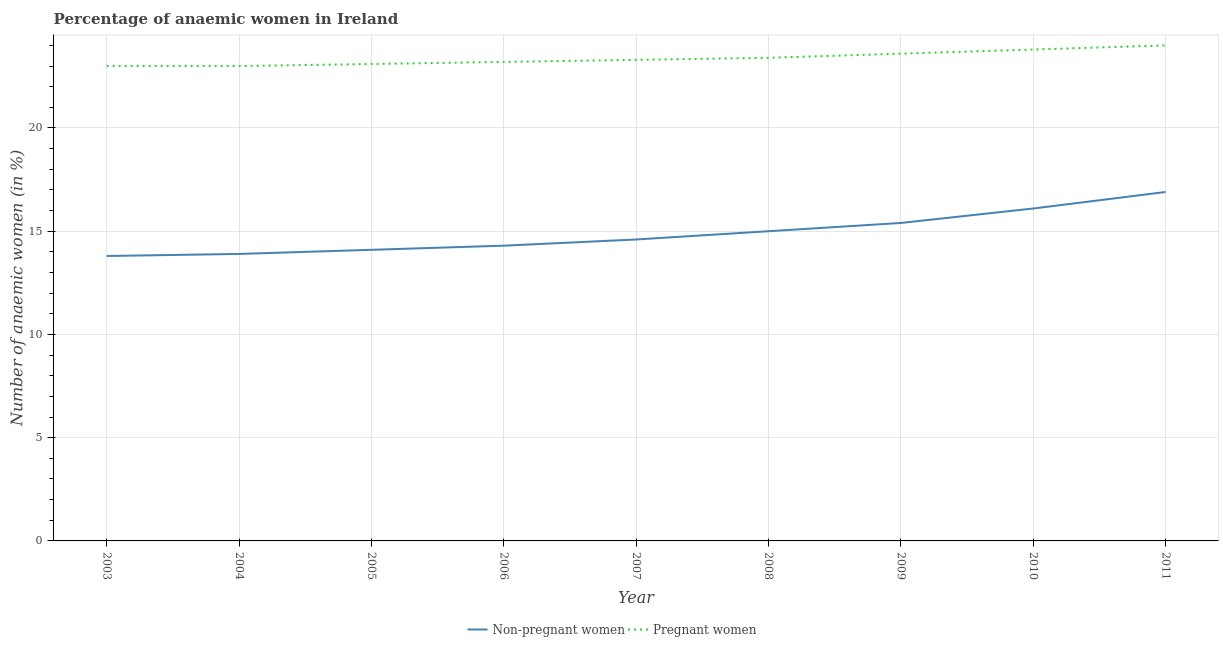Does the line corresponding to percentage of pregnant anaemic women intersect with the line corresponding to percentage of non-pregnant anaemic women?
Keep it short and to the point. No. Is the number of lines equal to the number of legend labels?
Provide a succinct answer. Yes. What is the percentage of pregnant anaemic women in 2008?
Give a very brief answer. 23.4. In which year was the percentage of non-pregnant anaemic women maximum?
Give a very brief answer. 2011. In which year was the percentage of non-pregnant anaemic women minimum?
Your answer should be very brief. 2003. What is the total percentage of non-pregnant anaemic women in the graph?
Your answer should be compact. 134.1. What is the difference between the percentage of pregnant anaemic women in 2006 and that in 2009?
Give a very brief answer. -0.4. What is the difference between the percentage of non-pregnant anaemic women in 2005 and the percentage of pregnant anaemic women in 2009?
Give a very brief answer. -9.5. What is the average percentage of pregnant anaemic women per year?
Your answer should be compact. 23.38. In the year 2009, what is the difference between the percentage of non-pregnant anaemic women and percentage of pregnant anaemic women?
Keep it short and to the point. -8.2. What is the ratio of the percentage of pregnant anaemic women in 2009 to that in 2011?
Your answer should be very brief. 0.98. Is the percentage of non-pregnant anaemic women in 2005 less than that in 2006?
Your response must be concise. Yes. Is the difference between the percentage of non-pregnant anaemic women in 2006 and 2011 greater than the difference between the percentage of pregnant anaemic women in 2006 and 2011?
Offer a very short reply. No. What is the difference between the highest and the second highest percentage of pregnant anaemic women?
Ensure brevity in your answer.  0.2. What is the difference between the highest and the lowest percentage of non-pregnant anaemic women?
Your answer should be compact. 3.1. Is the sum of the percentage of non-pregnant anaemic women in 2004 and 2011 greater than the maximum percentage of pregnant anaemic women across all years?
Give a very brief answer. Yes. Is the percentage of pregnant anaemic women strictly greater than the percentage of non-pregnant anaemic women over the years?
Give a very brief answer. Yes. How many years are there in the graph?
Ensure brevity in your answer.  9. Are the values on the major ticks of Y-axis written in scientific E-notation?
Offer a very short reply. No. Does the graph contain grids?
Give a very brief answer. Yes. Where does the legend appear in the graph?
Make the answer very short. Bottom center. How many legend labels are there?
Give a very brief answer. 2. How are the legend labels stacked?
Your answer should be compact. Horizontal. What is the title of the graph?
Your response must be concise. Percentage of anaemic women in Ireland. Does "Subsidies" appear as one of the legend labels in the graph?
Make the answer very short. No. What is the label or title of the Y-axis?
Your response must be concise. Number of anaemic women (in %). What is the Number of anaemic women (in %) of Pregnant women in 2004?
Provide a succinct answer. 23. What is the Number of anaemic women (in %) in Non-pregnant women in 2005?
Your answer should be compact. 14.1. What is the Number of anaemic women (in %) of Pregnant women in 2005?
Your answer should be very brief. 23.1. What is the Number of anaemic women (in %) of Pregnant women in 2006?
Your response must be concise. 23.2. What is the Number of anaemic women (in %) of Pregnant women in 2007?
Keep it short and to the point. 23.3. What is the Number of anaemic women (in %) in Pregnant women in 2008?
Offer a terse response. 23.4. What is the Number of anaemic women (in %) in Non-pregnant women in 2009?
Ensure brevity in your answer.  15.4. What is the Number of anaemic women (in %) of Pregnant women in 2009?
Give a very brief answer. 23.6. What is the Number of anaemic women (in %) in Non-pregnant women in 2010?
Offer a very short reply. 16.1. What is the Number of anaemic women (in %) in Pregnant women in 2010?
Provide a succinct answer. 23.8. What is the Number of anaemic women (in %) of Non-pregnant women in 2011?
Make the answer very short. 16.9. What is the Number of anaemic women (in %) of Pregnant women in 2011?
Ensure brevity in your answer.  24. Across all years, what is the maximum Number of anaemic women (in %) of Pregnant women?
Make the answer very short. 24. Across all years, what is the minimum Number of anaemic women (in %) of Non-pregnant women?
Your answer should be compact. 13.8. Across all years, what is the minimum Number of anaemic women (in %) of Pregnant women?
Your response must be concise. 23. What is the total Number of anaemic women (in %) in Non-pregnant women in the graph?
Make the answer very short. 134.1. What is the total Number of anaemic women (in %) in Pregnant women in the graph?
Give a very brief answer. 210.4. What is the difference between the Number of anaemic women (in %) in Non-pregnant women in 2003 and that in 2004?
Your answer should be very brief. -0.1. What is the difference between the Number of anaemic women (in %) of Non-pregnant women in 2003 and that in 2007?
Make the answer very short. -0.8. What is the difference between the Number of anaemic women (in %) of Pregnant women in 2003 and that in 2007?
Offer a very short reply. -0.3. What is the difference between the Number of anaemic women (in %) of Non-pregnant women in 2003 and that in 2008?
Provide a short and direct response. -1.2. What is the difference between the Number of anaemic women (in %) in Pregnant women in 2003 and that in 2008?
Your answer should be very brief. -0.4. What is the difference between the Number of anaemic women (in %) in Non-pregnant women in 2003 and that in 2009?
Keep it short and to the point. -1.6. What is the difference between the Number of anaemic women (in %) of Non-pregnant women in 2003 and that in 2010?
Your answer should be compact. -2.3. What is the difference between the Number of anaemic women (in %) of Pregnant women in 2004 and that in 2005?
Ensure brevity in your answer.  -0.1. What is the difference between the Number of anaemic women (in %) in Non-pregnant women in 2004 and that in 2007?
Offer a terse response. -0.7. What is the difference between the Number of anaemic women (in %) of Non-pregnant women in 2004 and that in 2008?
Offer a terse response. -1.1. What is the difference between the Number of anaemic women (in %) in Pregnant women in 2004 and that in 2009?
Your answer should be very brief. -0.6. What is the difference between the Number of anaemic women (in %) of Non-pregnant women in 2004 and that in 2010?
Your answer should be very brief. -2.2. What is the difference between the Number of anaemic women (in %) in Pregnant women in 2004 and that in 2010?
Give a very brief answer. -0.8. What is the difference between the Number of anaemic women (in %) of Non-pregnant women in 2004 and that in 2011?
Ensure brevity in your answer.  -3. What is the difference between the Number of anaemic women (in %) in Pregnant women in 2004 and that in 2011?
Provide a short and direct response. -1. What is the difference between the Number of anaemic women (in %) of Non-pregnant women in 2005 and that in 2006?
Your answer should be compact. -0.2. What is the difference between the Number of anaemic women (in %) of Pregnant women in 2005 and that in 2006?
Offer a very short reply. -0.1. What is the difference between the Number of anaemic women (in %) in Pregnant women in 2005 and that in 2009?
Ensure brevity in your answer.  -0.5. What is the difference between the Number of anaemic women (in %) in Pregnant women in 2005 and that in 2010?
Offer a terse response. -0.7. What is the difference between the Number of anaemic women (in %) of Non-pregnant women in 2005 and that in 2011?
Keep it short and to the point. -2.8. What is the difference between the Number of anaemic women (in %) in Non-pregnant women in 2006 and that in 2009?
Offer a terse response. -1.1. What is the difference between the Number of anaemic women (in %) in Pregnant women in 2006 and that in 2009?
Your answer should be very brief. -0.4. What is the difference between the Number of anaemic women (in %) of Non-pregnant women in 2006 and that in 2011?
Keep it short and to the point. -2.6. What is the difference between the Number of anaemic women (in %) in Pregnant women in 2007 and that in 2008?
Provide a succinct answer. -0.1. What is the difference between the Number of anaemic women (in %) in Pregnant women in 2007 and that in 2009?
Offer a very short reply. -0.3. What is the difference between the Number of anaemic women (in %) in Pregnant women in 2008 and that in 2011?
Your answer should be very brief. -0.6. What is the difference between the Number of anaemic women (in %) in Non-pregnant women in 2009 and that in 2010?
Offer a terse response. -0.7. What is the difference between the Number of anaemic women (in %) in Pregnant women in 2009 and that in 2010?
Keep it short and to the point. -0.2. What is the difference between the Number of anaemic women (in %) in Non-pregnant women in 2003 and the Number of anaemic women (in %) in Pregnant women in 2004?
Give a very brief answer. -9.2. What is the difference between the Number of anaemic women (in %) of Non-pregnant women in 2003 and the Number of anaemic women (in %) of Pregnant women in 2011?
Provide a short and direct response. -10.2. What is the difference between the Number of anaemic women (in %) in Non-pregnant women in 2004 and the Number of anaemic women (in %) in Pregnant women in 2005?
Your response must be concise. -9.2. What is the difference between the Number of anaemic women (in %) in Non-pregnant women in 2004 and the Number of anaemic women (in %) in Pregnant women in 2007?
Your response must be concise. -9.4. What is the difference between the Number of anaemic women (in %) in Non-pregnant women in 2004 and the Number of anaemic women (in %) in Pregnant women in 2008?
Keep it short and to the point. -9.5. What is the difference between the Number of anaemic women (in %) in Non-pregnant women in 2004 and the Number of anaemic women (in %) in Pregnant women in 2010?
Give a very brief answer. -9.9. What is the difference between the Number of anaemic women (in %) in Non-pregnant women in 2005 and the Number of anaemic women (in %) in Pregnant women in 2006?
Make the answer very short. -9.1. What is the difference between the Number of anaemic women (in %) in Non-pregnant women in 2005 and the Number of anaemic women (in %) in Pregnant women in 2007?
Ensure brevity in your answer.  -9.2. What is the difference between the Number of anaemic women (in %) in Non-pregnant women in 2005 and the Number of anaemic women (in %) in Pregnant women in 2008?
Your answer should be very brief. -9.3. What is the difference between the Number of anaemic women (in %) in Non-pregnant women in 2006 and the Number of anaemic women (in %) in Pregnant women in 2007?
Your response must be concise. -9. What is the difference between the Number of anaemic women (in %) of Non-pregnant women in 2006 and the Number of anaemic women (in %) of Pregnant women in 2008?
Provide a succinct answer. -9.1. What is the difference between the Number of anaemic women (in %) of Non-pregnant women in 2006 and the Number of anaemic women (in %) of Pregnant women in 2011?
Offer a very short reply. -9.7. What is the difference between the Number of anaemic women (in %) of Non-pregnant women in 2007 and the Number of anaemic women (in %) of Pregnant women in 2008?
Your response must be concise. -8.8. What is the difference between the Number of anaemic women (in %) of Non-pregnant women in 2007 and the Number of anaemic women (in %) of Pregnant women in 2011?
Offer a terse response. -9.4. What is the difference between the Number of anaemic women (in %) in Non-pregnant women in 2008 and the Number of anaemic women (in %) in Pregnant women in 2011?
Offer a terse response. -9. What is the average Number of anaemic women (in %) of Non-pregnant women per year?
Offer a terse response. 14.9. What is the average Number of anaemic women (in %) in Pregnant women per year?
Your response must be concise. 23.38. In the year 2003, what is the difference between the Number of anaemic women (in %) of Non-pregnant women and Number of anaemic women (in %) of Pregnant women?
Your response must be concise. -9.2. In the year 2005, what is the difference between the Number of anaemic women (in %) in Non-pregnant women and Number of anaemic women (in %) in Pregnant women?
Offer a terse response. -9. In the year 2006, what is the difference between the Number of anaemic women (in %) of Non-pregnant women and Number of anaemic women (in %) of Pregnant women?
Offer a very short reply. -8.9. In the year 2007, what is the difference between the Number of anaemic women (in %) of Non-pregnant women and Number of anaemic women (in %) of Pregnant women?
Your answer should be very brief. -8.7. In the year 2008, what is the difference between the Number of anaemic women (in %) of Non-pregnant women and Number of anaemic women (in %) of Pregnant women?
Keep it short and to the point. -8.4. In the year 2009, what is the difference between the Number of anaemic women (in %) in Non-pregnant women and Number of anaemic women (in %) in Pregnant women?
Your answer should be very brief. -8.2. What is the ratio of the Number of anaemic women (in %) in Pregnant women in 2003 to that in 2004?
Keep it short and to the point. 1. What is the ratio of the Number of anaemic women (in %) of Non-pregnant women in 2003 to that in 2005?
Provide a succinct answer. 0.98. What is the ratio of the Number of anaemic women (in %) in Pregnant women in 2003 to that in 2005?
Keep it short and to the point. 1. What is the ratio of the Number of anaemic women (in %) of Non-pregnant women in 2003 to that in 2007?
Make the answer very short. 0.95. What is the ratio of the Number of anaemic women (in %) of Pregnant women in 2003 to that in 2007?
Your answer should be very brief. 0.99. What is the ratio of the Number of anaemic women (in %) in Non-pregnant women in 2003 to that in 2008?
Offer a terse response. 0.92. What is the ratio of the Number of anaemic women (in %) in Pregnant women in 2003 to that in 2008?
Provide a succinct answer. 0.98. What is the ratio of the Number of anaemic women (in %) in Non-pregnant women in 2003 to that in 2009?
Provide a short and direct response. 0.9. What is the ratio of the Number of anaemic women (in %) of Pregnant women in 2003 to that in 2009?
Offer a terse response. 0.97. What is the ratio of the Number of anaemic women (in %) in Non-pregnant women in 2003 to that in 2010?
Offer a terse response. 0.86. What is the ratio of the Number of anaemic women (in %) in Pregnant women in 2003 to that in 2010?
Your answer should be compact. 0.97. What is the ratio of the Number of anaemic women (in %) in Non-pregnant women in 2003 to that in 2011?
Make the answer very short. 0.82. What is the ratio of the Number of anaemic women (in %) in Non-pregnant women in 2004 to that in 2005?
Keep it short and to the point. 0.99. What is the ratio of the Number of anaemic women (in %) in Pregnant women in 2004 to that in 2005?
Give a very brief answer. 1. What is the ratio of the Number of anaemic women (in %) in Non-pregnant women in 2004 to that in 2006?
Give a very brief answer. 0.97. What is the ratio of the Number of anaemic women (in %) in Non-pregnant women in 2004 to that in 2007?
Your answer should be very brief. 0.95. What is the ratio of the Number of anaemic women (in %) in Pregnant women in 2004 to that in 2007?
Provide a succinct answer. 0.99. What is the ratio of the Number of anaemic women (in %) of Non-pregnant women in 2004 to that in 2008?
Ensure brevity in your answer.  0.93. What is the ratio of the Number of anaemic women (in %) in Pregnant women in 2004 to that in 2008?
Give a very brief answer. 0.98. What is the ratio of the Number of anaemic women (in %) of Non-pregnant women in 2004 to that in 2009?
Your response must be concise. 0.9. What is the ratio of the Number of anaemic women (in %) in Pregnant women in 2004 to that in 2009?
Ensure brevity in your answer.  0.97. What is the ratio of the Number of anaemic women (in %) in Non-pregnant women in 2004 to that in 2010?
Provide a short and direct response. 0.86. What is the ratio of the Number of anaemic women (in %) in Pregnant women in 2004 to that in 2010?
Ensure brevity in your answer.  0.97. What is the ratio of the Number of anaemic women (in %) in Non-pregnant women in 2004 to that in 2011?
Give a very brief answer. 0.82. What is the ratio of the Number of anaemic women (in %) in Pregnant women in 2004 to that in 2011?
Give a very brief answer. 0.96. What is the ratio of the Number of anaemic women (in %) of Non-pregnant women in 2005 to that in 2006?
Give a very brief answer. 0.99. What is the ratio of the Number of anaemic women (in %) of Pregnant women in 2005 to that in 2006?
Your response must be concise. 1. What is the ratio of the Number of anaemic women (in %) of Non-pregnant women in 2005 to that in 2007?
Provide a short and direct response. 0.97. What is the ratio of the Number of anaemic women (in %) of Pregnant women in 2005 to that in 2007?
Your answer should be compact. 0.99. What is the ratio of the Number of anaemic women (in %) of Pregnant women in 2005 to that in 2008?
Keep it short and to the point. 0.99. What is the ratio of the Number of anaemic women (in %) of Non-pregnant women in 2005 to that in 2009?
Keep it short and to the point. 0.92. What is the ratio of the Number of anaemic women (in %) in Pregnant women in 2005 to that in 2009?
Your answer should be compact. 0.98. What is the ratio of the Number of anaemic women (in %) in Non-pregnant women in 2005 to that in 2010?
Your answer should be very brief. 0.88. What is the ratio of the Number of anaemic women (in %) in Pregnant women in 2005 to that in 2010?
Offer a very short reply. 0.97. What is the ratio of the Number of anaemic women (in %) in Non-pregnant women in 2005 to that in 2011?
Your answer should be compact. 0.83. What is the ratio of the Number of anaemic women (in %) in Pregnant women in 2005 to that in 2011?
Your answer should be very brief. 0.96. What is the ratio of the Number of anaemic women (in %) of Non-pregnant women in 2006 to that in 2007?
Ensure brevity in your answer.  0.98. What is the ratio of the Number of anaemic women (in %) of Non-pregnant women in 2006 to that in 2008?
Give a very brief answer. 0.95. What is the ratio of the Number of anaemic women (in %) of Pregnant women in 2006 to that in 2008?
Ensure brevity in your answer.  0.99. What is the ratio of the Number of anaemic women (in %) in Non-pregnant women in 2006 to that in 2009?
Your response must be concise. 0.93. What is the ratio of the Number of anaemic women (in %) in Pregnant women in 2006 to that in 2009?
Give a very brief answer. 0.98. What is the ratio of the Number of anaemic women (in %) of Non-pregnant women in 2006 to that in 2010?
Ensure brevity in your answer.  0.89. What is the ratio of the Number of anaemic women (in %) in Pregnant women in 2006 to that in 2010?
Keep it short and to the point. 0.97. What is the ratio of the Number of anaemic women (in %) of Non-pregnant women in 2006 to that in 2011?
Provide a short and direct response. 0.85. What is the ratio of the Number of anaemic women (in %) in Pregnant women in 2006 to that in 2011?
Keep it short and to the point. 0.97. What is the ratio of the Number of anaemic women (in %) in Non-pregnant women in 2007 to that in 2008?
Offer a terse response. 0.97. What is the ratio of the Number of anaemic women (in %) of Pregnant women in 2007 to that in 2008?
Provide a short and direct response. 1. What is the ratio of the Number of anaemic women (in %) of Non-pregnant women in 2007 to that in 2009?
Ensure brevity in your answer.  0.95. What is the ratio of the Number of anaemic women (in %) of Pregnant women in 2007 to that in 2009?
Provide a short and direct response. 0.99. What is the ratio of the Number of anaemic women (in %) of Non-pregnant women in 2007 to that in 2010?
Your answer should be very brief. 0.91. What is the ratio of the Number of anaemic women (in %) of Pregnant women in 2007 to that in 2010?
Your answer should be very brief. 0.98. What is the ratio of the Number of anaemic women (in %) of Non-pregnant women in 2007 to that in 2011?
Provide a short and direct response. 0.86. What is the ratio of the Number of anaemic women (in %) in Pregnant women in 2007 to that in 2011?
Your answer should be compact. 0.97. What is the ratio of the Number of anaemic women (in %) in Non-pregnant women in 2008 to that in 2009?
Give a very brief answer. 0.97. What is the ratio of the Number of anaemic women (in %) of Pregnant women in 2008 to that in 2009?
Give a very brief answer. 0.99. What is the ratio of the Number of anaemic women (in %) in Non-pregnant women in 2008 to that in 2010?
Your answer should be very brief. 0.93. What is the ratio of the Number of anaemic women (in %) of Pregnant women in 2008 to that in 2010?
Keep it short and to the point. 0.98. What is the ratio of the Number of anaemic women (in %) of Non-pregnant women in 2008 to that in 2011?
Provide a short and direct response. 0.89. What is the ratio of the Number of anaemic women (in %) of Non-pregnant women in 2009 to that in 2010?
Give a very brief answer. 0.96. What is the ratio of the Number of anaemic women (in %) in Pregnant women in 2009 to that in 2010?
Provide a succinct answer. 0.99. What is the ratio of the Number of anaemic women (in %) of Non-pregnant women in 2009 to that in 2011?
Keep it short and to the point. 0.91. What is the ratio of the Number of anaemic women (in %) in Pregnant women in 2009 to that in 2011?
Offer a very short reply. 0.98. What is the ratio of the Number of anaemic women (in %) in Non-pregnant women in 2010 to that in 2011?
Offer a very short reply. 0.95. What is the difference between the highest and the lowest Number of anaemic women (in %) in Non-pregnant women?
Provide a short and direct response. 3.1. 